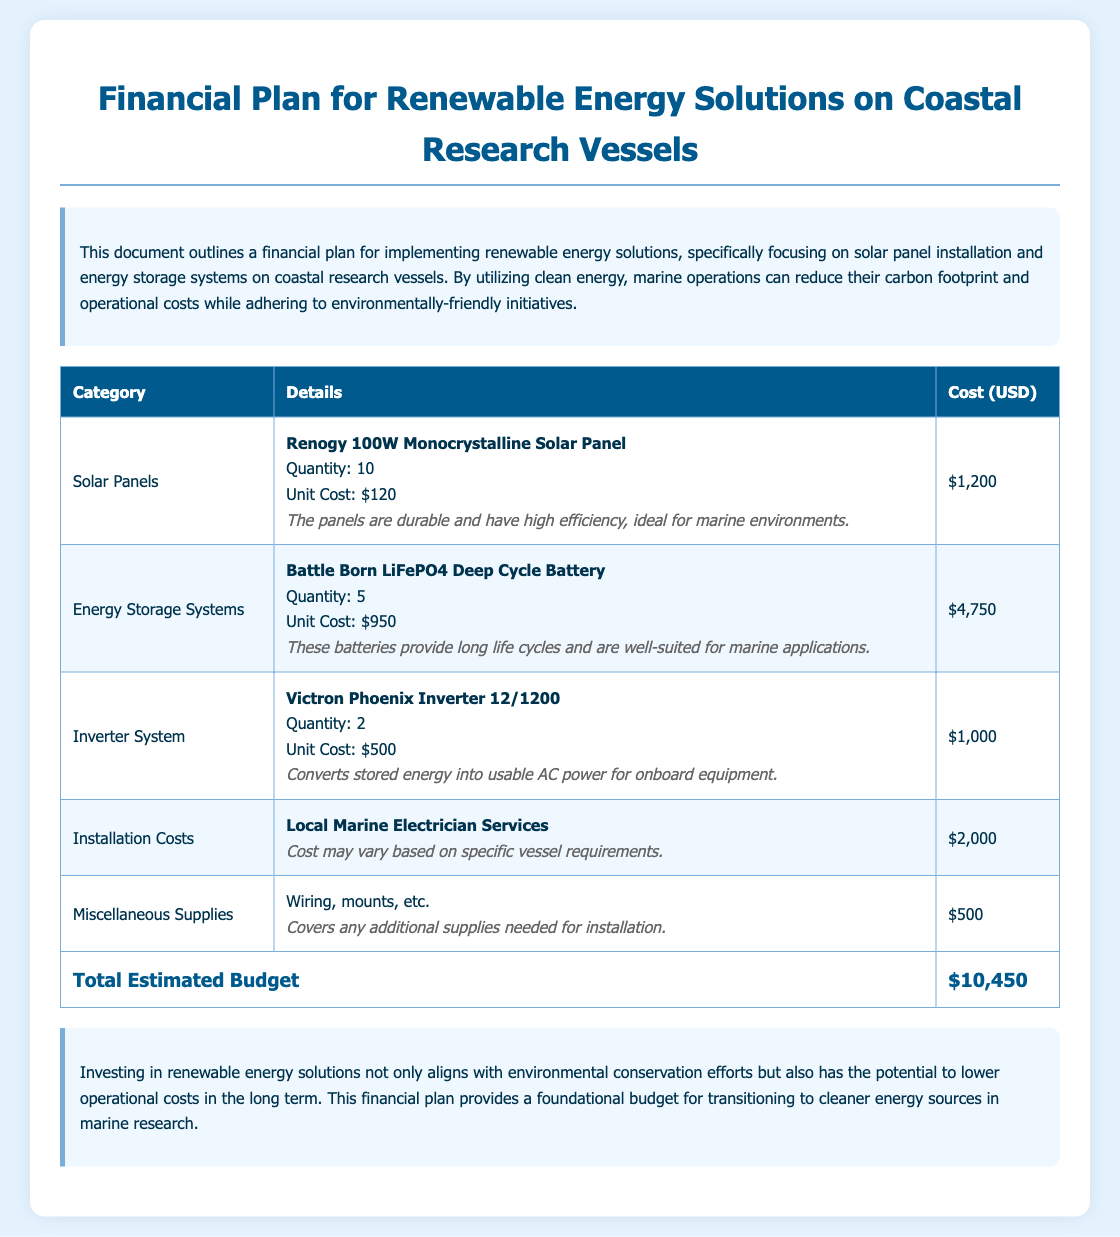what is the total estimated budget? The total estimated budget is listed at the bottom of the table, summarizing all the costs.
Answer: $10,450 how many solar panels are included in the budget? The budget specifies that there are 10 solar panels listed under Solar Panels.
Answer: 10 what is the unit cost of one energy storage system? The unit cost for one Battle Born LiFePO4 Deep Cycle Battery is mentioned in the details section.
Answer: $950 what type of inverter is included in the plan? The type of inverter mentioned in the document is the Victron Phoenix Inverter 12/1200.
Answer: Victron Phoenix Inverter 12/1200 how much is allocated for installation costs? The installation costs section explicitly states the budget allocation for electrician services.
Answer: $2,000 which company manufactures the solar panels? The solar panels in the budget are manufactured by Renogy, as indicated in the details.
Answer: Renogy what is the combined cost of energy storage systems and inverters? This requires adding the cost of energy storage systems and inverters, summarized in the table.
Answer: $5,750 what is the purpose of the miscellaneous supplies budget? The miscellaneous supplies cover additional installation components as detailed in their explanation.
Answer: Additional supplies needed for installation 